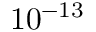<formula> <loc_0><loc_0><loc_500><loc_500>1 0 ^ { - 1 3 }</formula> 